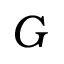Convert formula to latex. <formula><loc_0><loc_0><loc_500><loc_500>G</formula> 